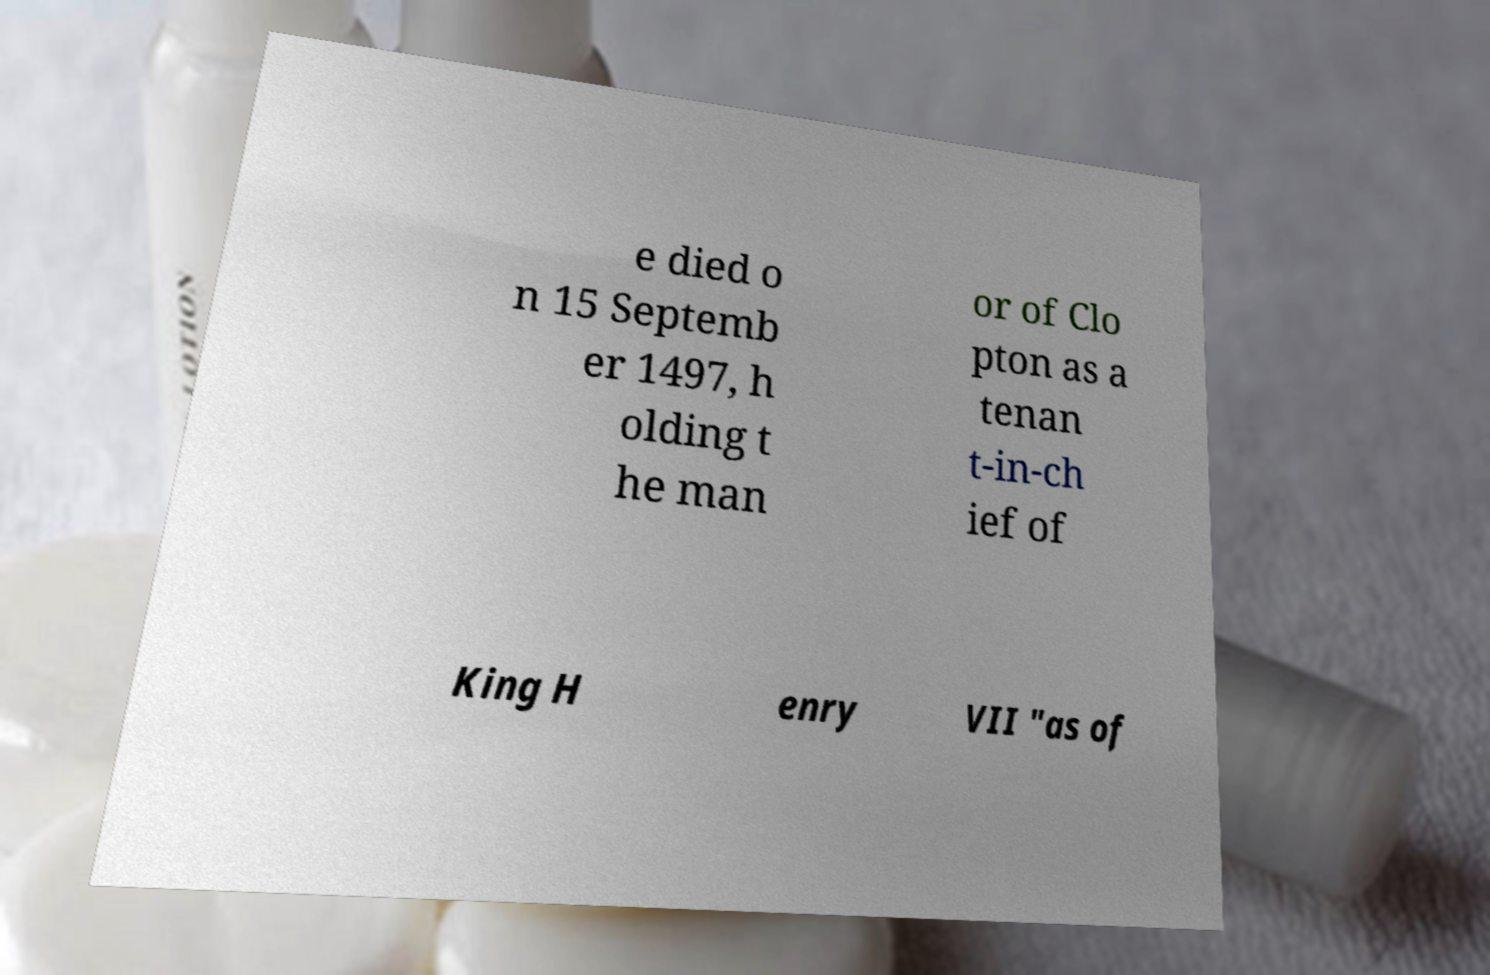There's text embedded in this image that I need extracted. Can you transcribe it verbatim? e died o n 15 Septemb er 1497, h olding t he man or of Clo pton as a tenan t-in-ch ief of King H enry VII "as of 